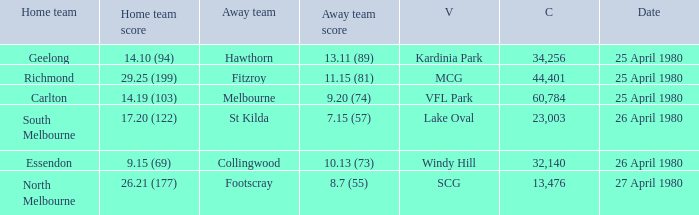Can you give me this table as a dict? {'header': ['Home team', 'Home team score', 'Away team', 'Away team score', 'V', 'C', 'Date'], 'rows': [['Geelong', '14.10 (94)', 'Hawthorn', '13.11 (89)', 'Kardinia Park', '34,256', '25 April 1980'], ['Richmond', '29.25 (199)', 'Fitzroy', '11.15 (81)', 'MCG', '44,401', '25 April 1980'], ['Carlton', '14.19 (103)', 'Melbourne', '9.20 (74)', 'VFL Park', '60,784', '25 April 1980'], ['South Melbourne', '17.20 (122)', 'St Kilda', '7.15 (57)', 'Lake Oval', '23,003', '26 April 1980'], ['Essendon', '9.15 (69)', 'Collingwood', '10.13 (73)', 'Windy Hill', '32,140', '26 April 1980'], ['North Melbourne', '26.21 (177)', 'Footscray', '8.7 (55)', 'SCG', '13,476', '27 April 1980']]} What was the lowest crowd size at MCG? 44401.0. 